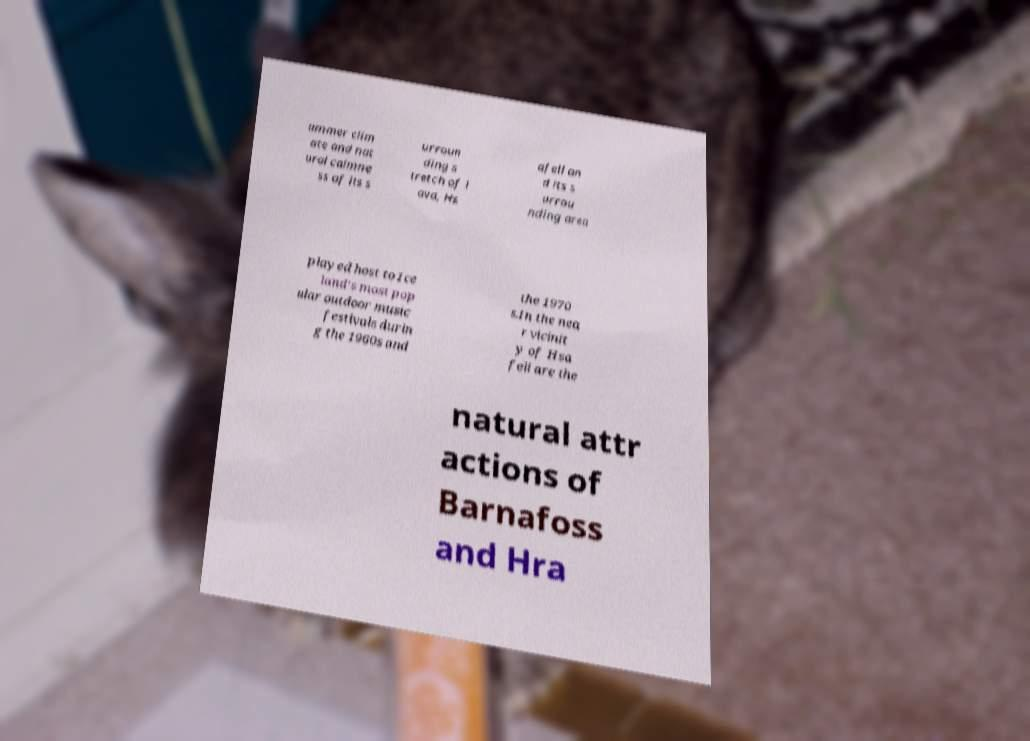Please identify and transcribe the text found in this image. ummer clim ate and nat ural calmne ss of its s urroun ding s tretch of l ava, Hs afell an d its s urrou nding area played host to Ice land's most pop ular outdoor music festivals durin g the 1960s and the 1970 s.In the nea r vicinit y of Hsa fell are the natural attr actions of Barnafoss and Hra 